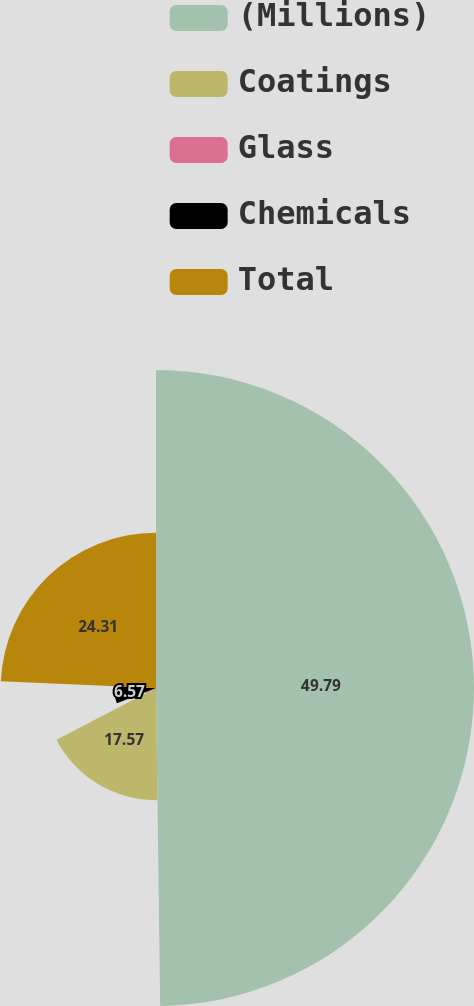<chart> <loc_0><loc_0><loc_500><loc_500><pie_chart><fcel>(Millions)<fcel>Coatings<fcel>Glass<fcel>Chemicals<fcel>Total<nl><fcel>49.79%<fcel>17.57%<fcel>1.76%<fcel>6.57%<fcel>24.31%<nl></chart> 